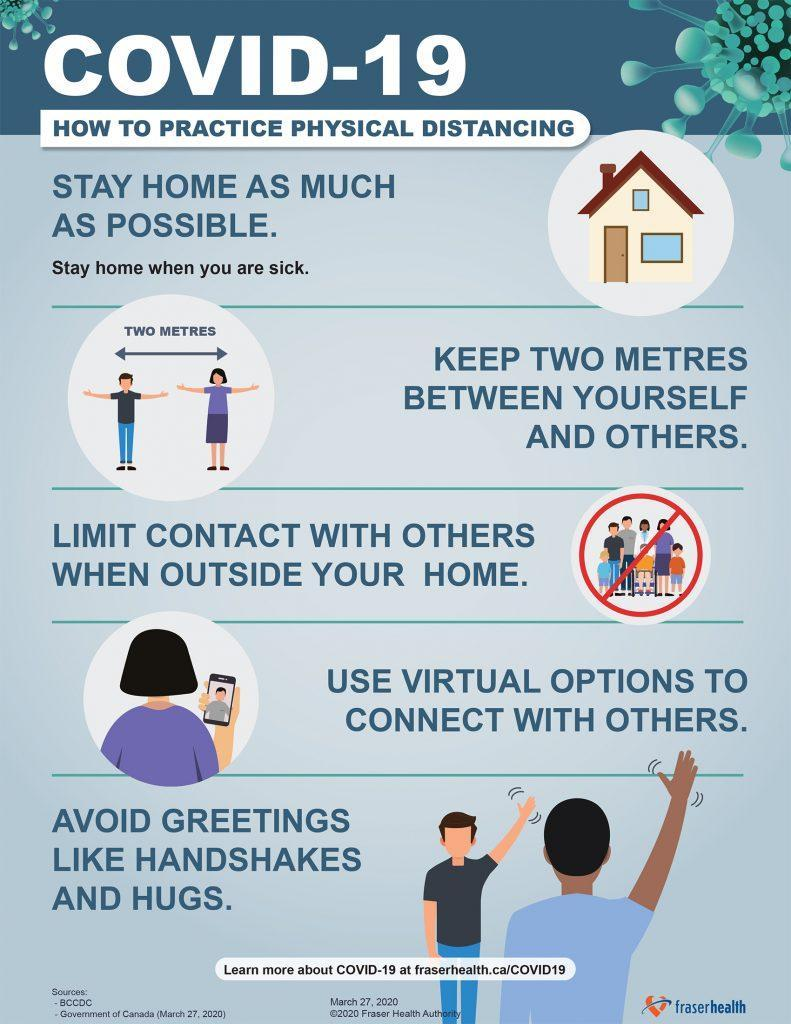What is the minimum safe distance to be maintained between one another inorder to control the spread of COVID-19 virus?
Answer the question with a short phrase. TWO METRES 